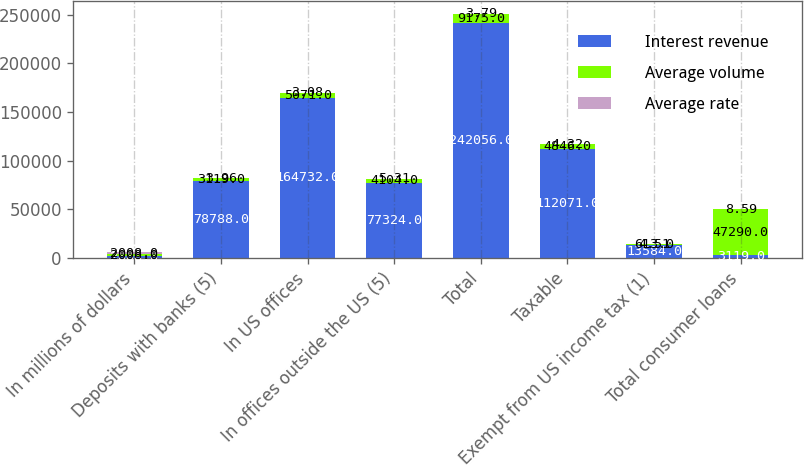<chart> <loc_0><loc_0><loc_500><loc_500><stacked_bar_chart><ecel><fcel>In millions of dollars<fcel>Deposits with banks (5)<fcel>In US offices<fcel>In offices outside the US (5)<fcel>Total<fcel>Taxable<fcel>Exempt from US income tax (1)<fcel>Total consumer loans<nl><fcel>Interest revenue<fcel>2008<fcel>78788<fcel>164732<fcel>77324<fcel>242056<fcel>112071<fcel>13584<fcel>3119<nl><fcel>Average volume<fcel>2008<fcel>3119<fcel>5071<fcel>4104<fcel>9175<fcel>4846<fcel>613<fcel>47290<nl><fcel>Average rate<fcel>2008<fcel>3.96<fcel>3.08<fcel>5.31<fcel>3.79<fcel>4.32<fcel>4.51<fcel>8.59<nl></chart> 